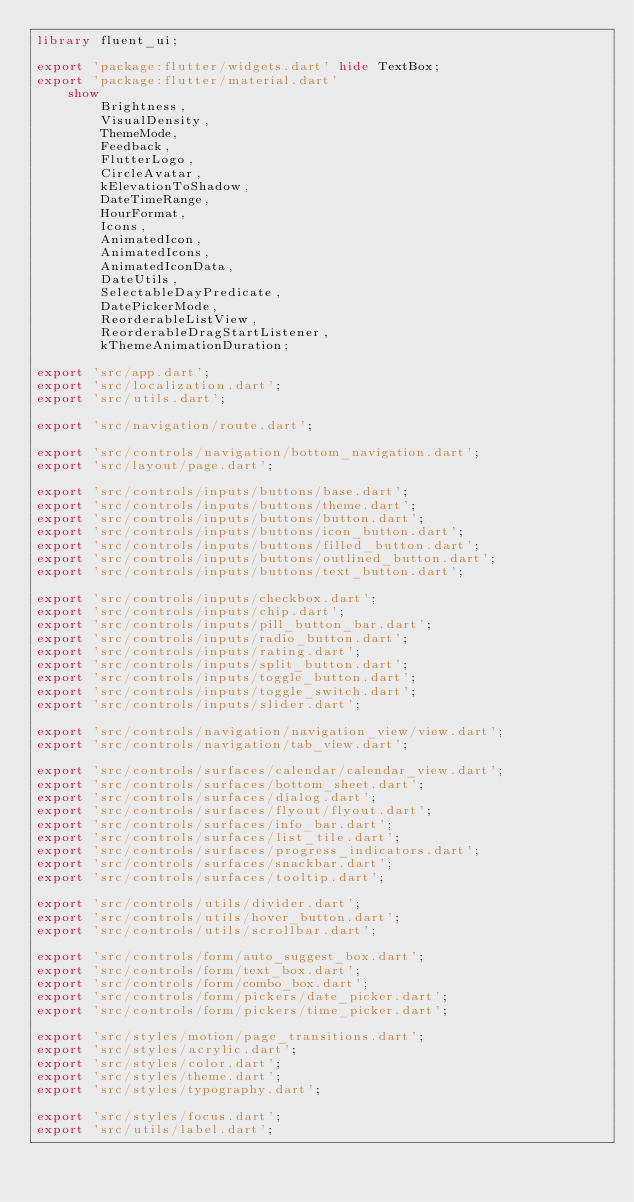<code> <loc_0><loc_0><loc_500><loc_500><_Dart_>library fluent_ui;

export 'package:flutter/widgets.dart' hide TextBox;
export 'package:flutter/material.dart'
    show
        Brightness,
        VisualDensity,
        ThemeMode,
        Feedback,
        FlutterLogo,
        CircleAvatar,
        kElevationToShadow,
        DateTimeRange,
        HourFormat,
        Icons,
        AnimatedIcon,
        AnimatedIcons,
        AnimatedIconData,
        DateUtils,
        SelectableDayPredicate,
        DatePickerMode,
        ReorderableListView,
        ReorderableDragStartListener,
        kThemeAnimationDuration;

export 'src/app.dart';
export 'src/localization.dart';
export 'src/utils.dart';

export 'src/navigation/route.dart';

export 'src/controls/navigation/bottom_navigation.dart';
export 'src/layout/page.dart';

export 'src/controls/inputs/buttons/base.dart';
export 'src/controls/inputs/buttons/theme.dart';
export 'src/controls/inputs/buttons/button.dart';
export 'src/controls/inputs/buttons/icon_button.dart';
export 'src/controls/inputs/buttons/filled_button.dart';
export 'src/controls/inputs/buttons/outlined_button.dart';
export 'src/controls/inputs/buttons/text_button.dart';

export 'src/controls/inputs/checkbox.dart';
export 'src/controls/inputs/chip.dart';
export 'src/controls/inputs/pill_button_bar.dart';
export 'src/controls/inputs/radio_button.dart';
export 'src/controls/inputs/rating.dart';
export 'src/controls/inputs/split_button.dart';
export 'src/controls/inputs/toggle_button.dart';
export 'src/controls/inputs/toggle_switch.dart';
export 'src/controls/inputs/slider.dart';

export 'src/controls/navigation/navigation_view/view.dart';
export 'src/controls/navigation/tab_view.dart';

export 'src/controls/surfaces/calendar/calendar_view.dart';
export 'src/controls/surfaces/bottom_sheet.dart';
export 'src/controls/surfaces/dialog.dart';
export 'src/controls/surfaces/flyout/flyout.dart';
export 'src/controls/surfaces/info_bar.dart';
export 'src/controls/surfaces/list_tile.dart';
export 'src/controls/surfaces/progress_indicators.dart';
export 'src/controls/surfaces/snackbar.dart';
export 'src/controls/surfaces/tooltip.dart';

export 'src/controls/utils/divider.dart';
export 'src/controls/utils/hover_button.dart';
export 'src/controls/utils/scrollbar.dart';

export 'src/controls/form/auto_suggest_box.dart';
export 'src/controls/form/text_box.dart';
export 'src/controls/form/combo_box.dart';
export 'src/controls/form/pickers/date_picker.dart';
export 'src/controls/form/pickers/time_picker.dart';

export 'src/styles/motion/page_transitions.dart';
export 'src/styles/acrylic.dart';
export 'src/styles/color.dart';
export 'src/styles/theme.dart';
export 'src/styles/typography.dart';

export 'src/styles/focus.dart';
export 'src/utils/label.dart';
</code> 